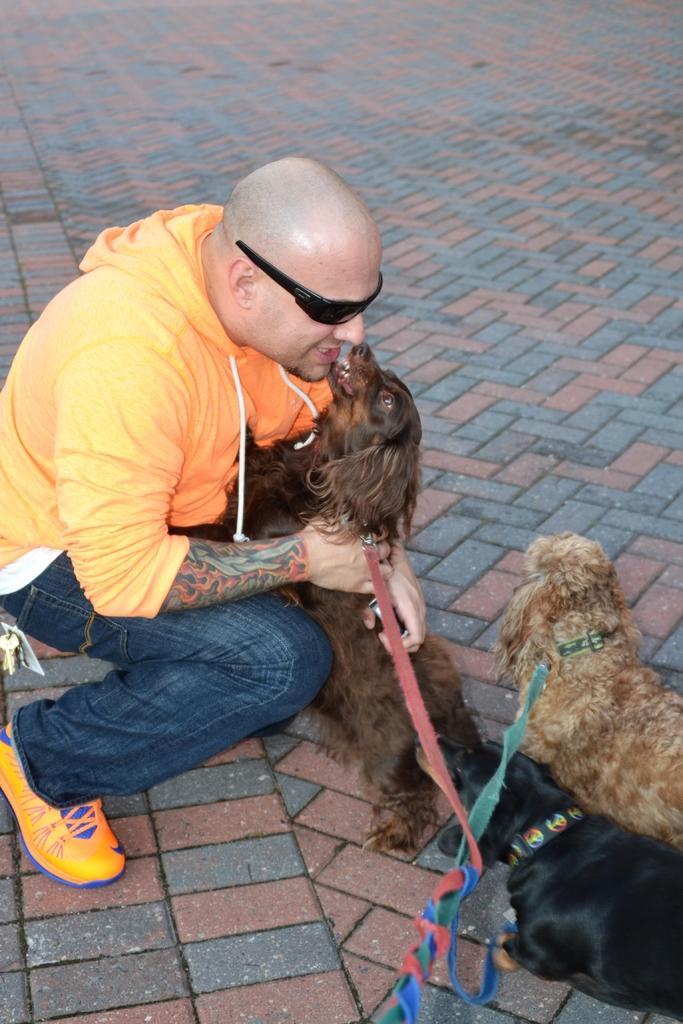In one or two sentences, can you explain what this image depicts? In this image i can see a person holding a dog and to the right of the image i can see 2 other dogs. 